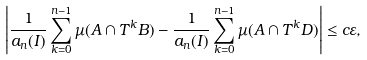<formula> <loc_0><loc_0><loc_500><loc_500>\left | \frac { 1 } { a _ { n } ( I ) } \sum _ { k = 0 } ^ { n - 1 } \mu ( A \cap T ^ { k } B ) - \frac { 1 } { a _ { n } ( I ) } \sum _ { k = 0 } ^ { n - 1 } \mu ( A \cap T ^ { k } D ) \right | \leq c \varepsilon ,</formula> 